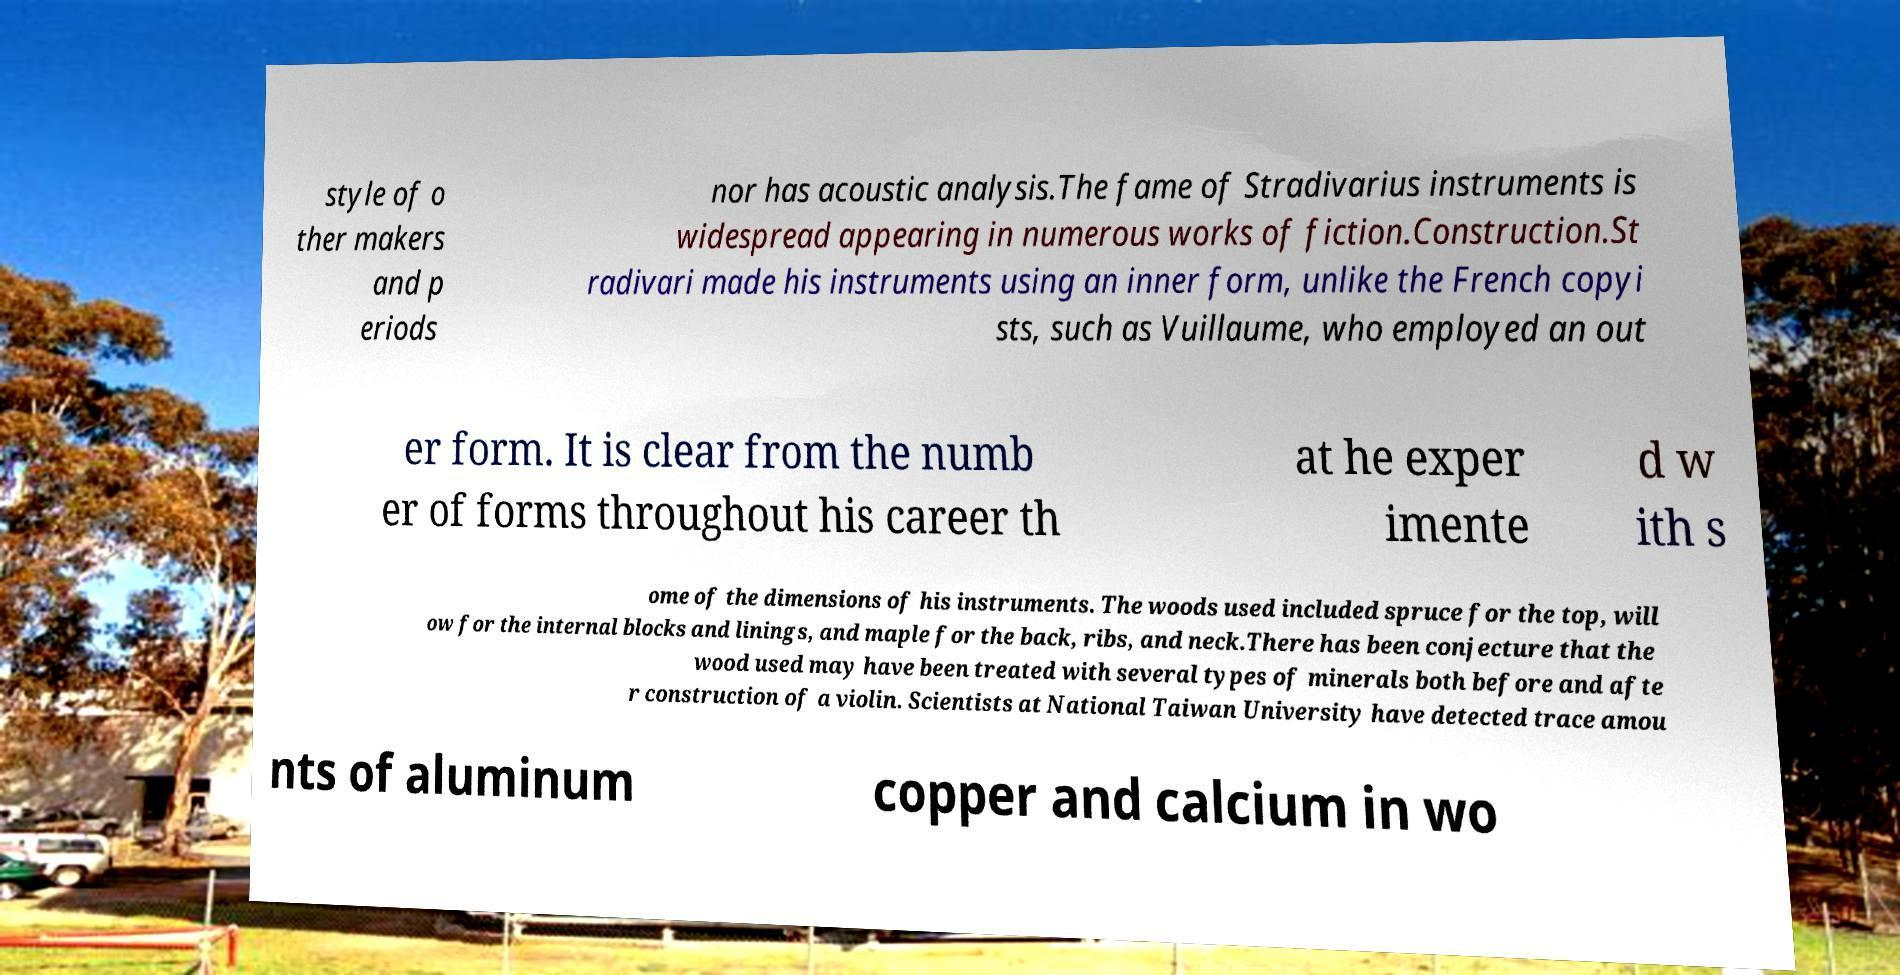Please identify and transcribe the text found in this image. style of o ther makers and p eriods nor has acoustic analysis.The fame of Stradivarius instruments is widespread appearing in numerous works of fiction.Construction.St radivari made his instruments using an inner form, unlike the French copyi sts, such as Vuillaume, who employed an out er form. It is clear from the numb er of forms throughout his career th at he exper imente d w ith s ome of the dimensions of his instruments. The woods used included spruce for the top, will ow for the internal blocks and linings, and maple for the back, ribs, and neck.There has been conjecture that the wood used may have been treated with several types of minerals both before and afte r construction of a violin. Scientists at National Taiwan University have detected trace amou nts of aluminum copper and calcium in wo 